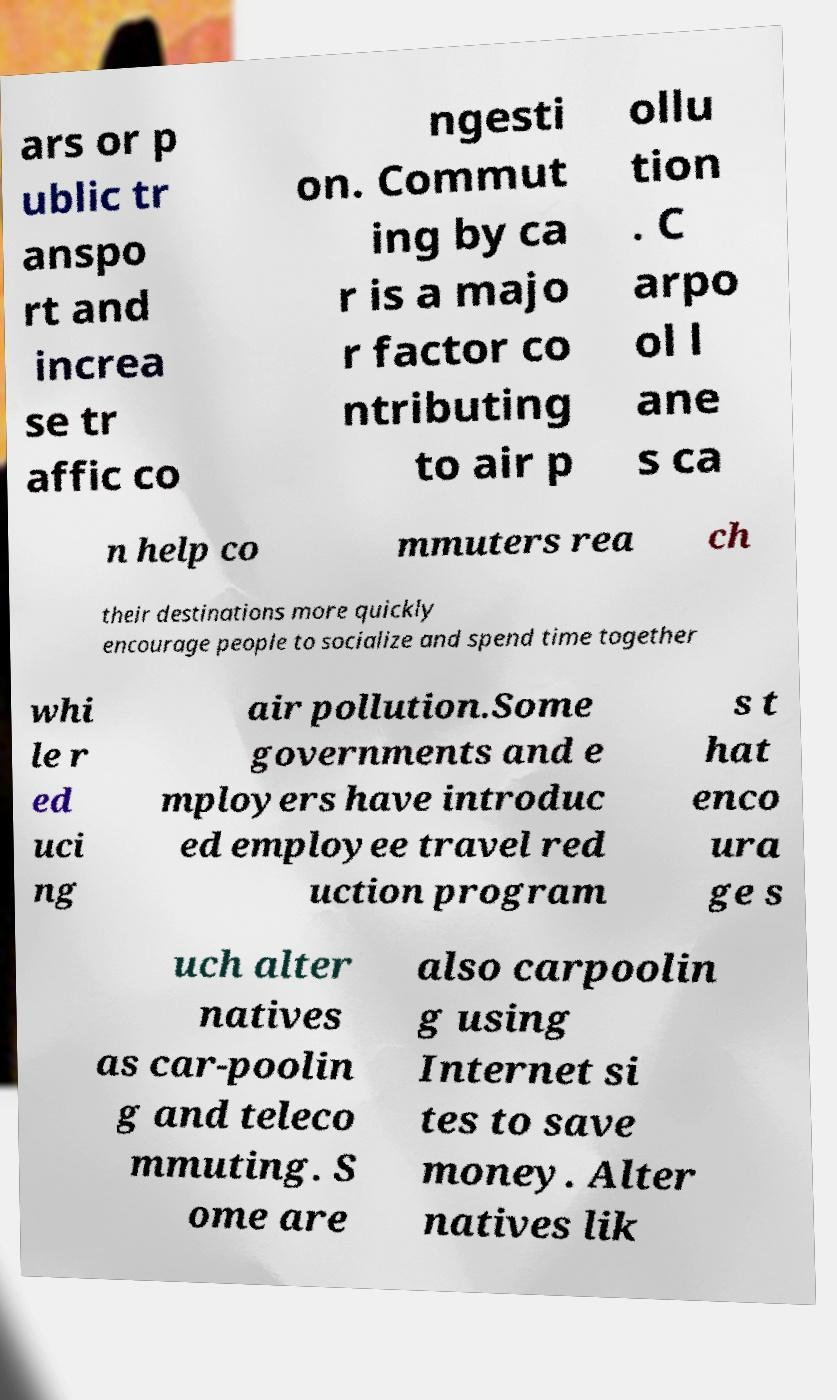Can you read and provide the text displayed in the image?This photo seems to have some interesting text. Can you extract and type it out for me? ars or p ublic tr anspo rt and increa se tr affic co ngesti on. Commut ing by ca r is a majo r factor co ntributing to air p ollu tion . C arpo ol l ane s ca n help co mmuters rea ch their destinations more quickly encourage people to socialize and spend time together whi le r ed uci ng air pollution.Some governments and e mployers have introduc ed employee travel red uction program s t hat enco ura ge s uch alter natives as car-poolin g and teleco mmuting. S ome are also carpoolin g using Internet si tes to save money. Alter natives lik 